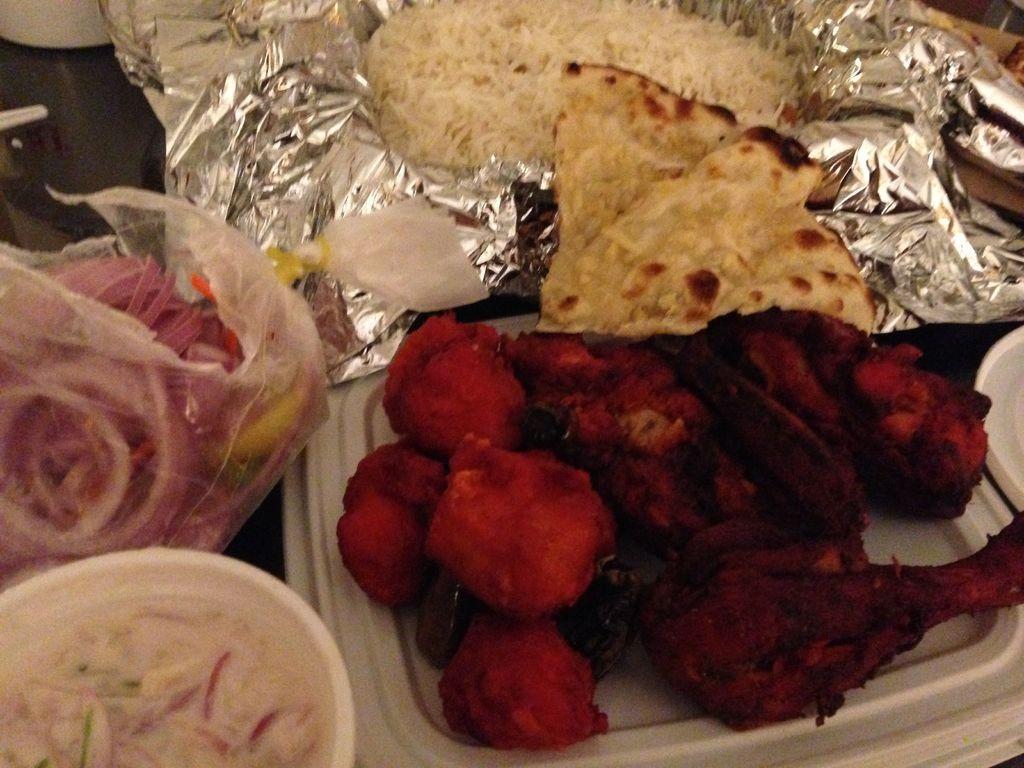Could you give a brief overview of what you see in this image? In this image we can see different kinds of foods placed in polythene containers and polythene covers. 